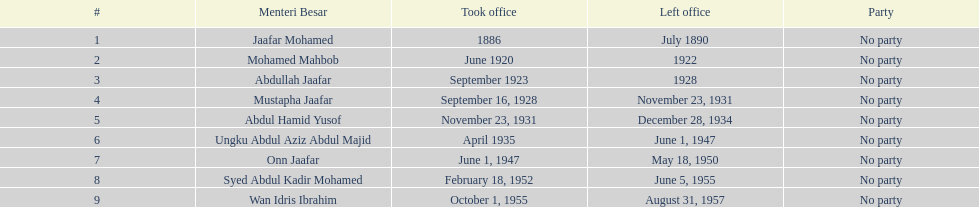How lengthy was ungku abdul aziz abdul majid's service? 12 years. 